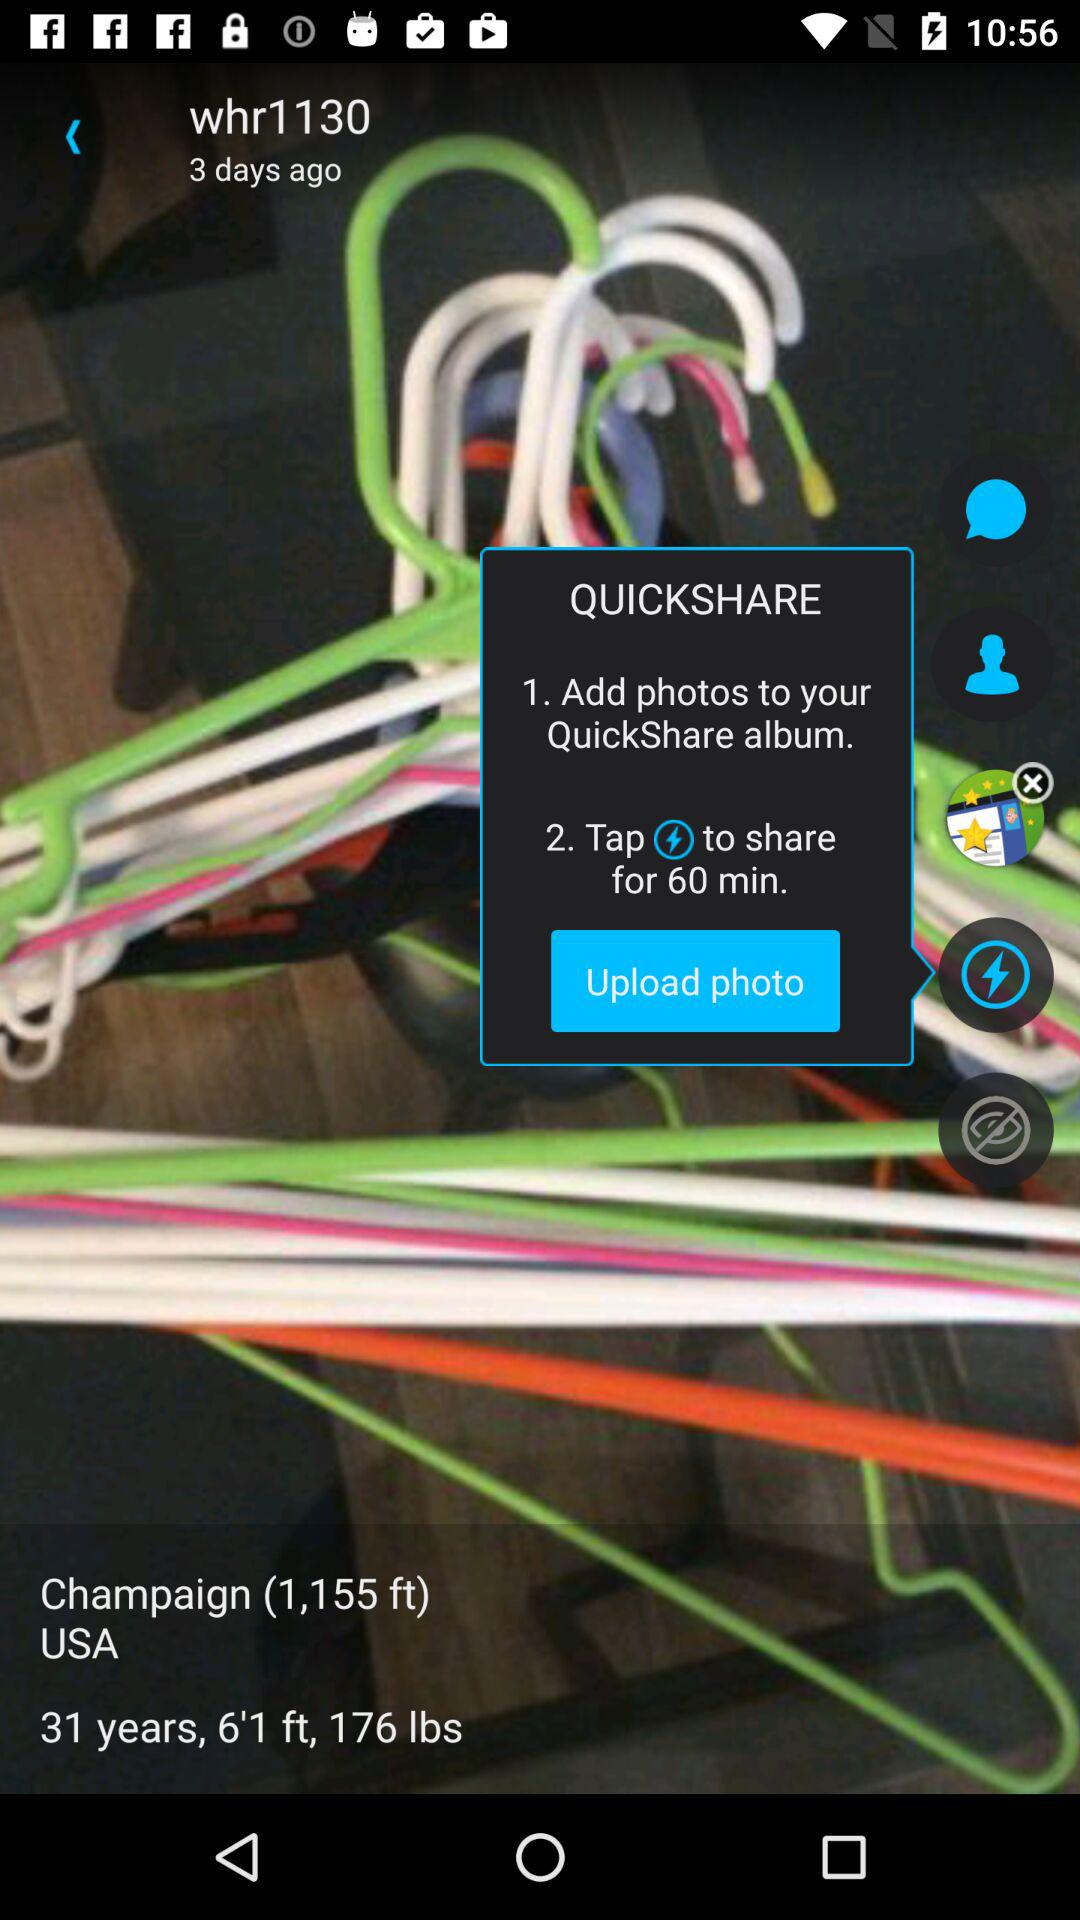What is the age? The age is 31 years. 